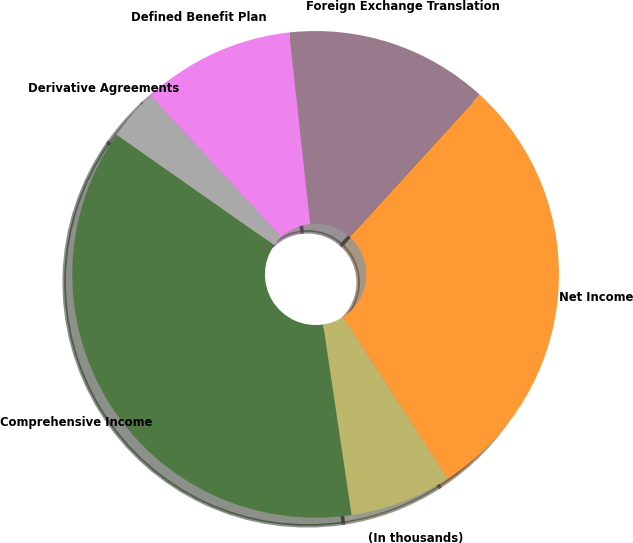<chart> <loc_0><loc_0><loc_500><loc_500><pie_chart><fcel>(In thousands)<fcel>Net Income<fcel>Foreign Exchange Translation<fcel>Defined Benefit Plan<fcel>Derivative Agreements<fcel>Comprehensive Income<nl><fcel>6.77%<fcel>29.1%<fcel>13.51%<fcel>10.14%<fcel>3.39%<fcel>37.09%<nl></chart> 